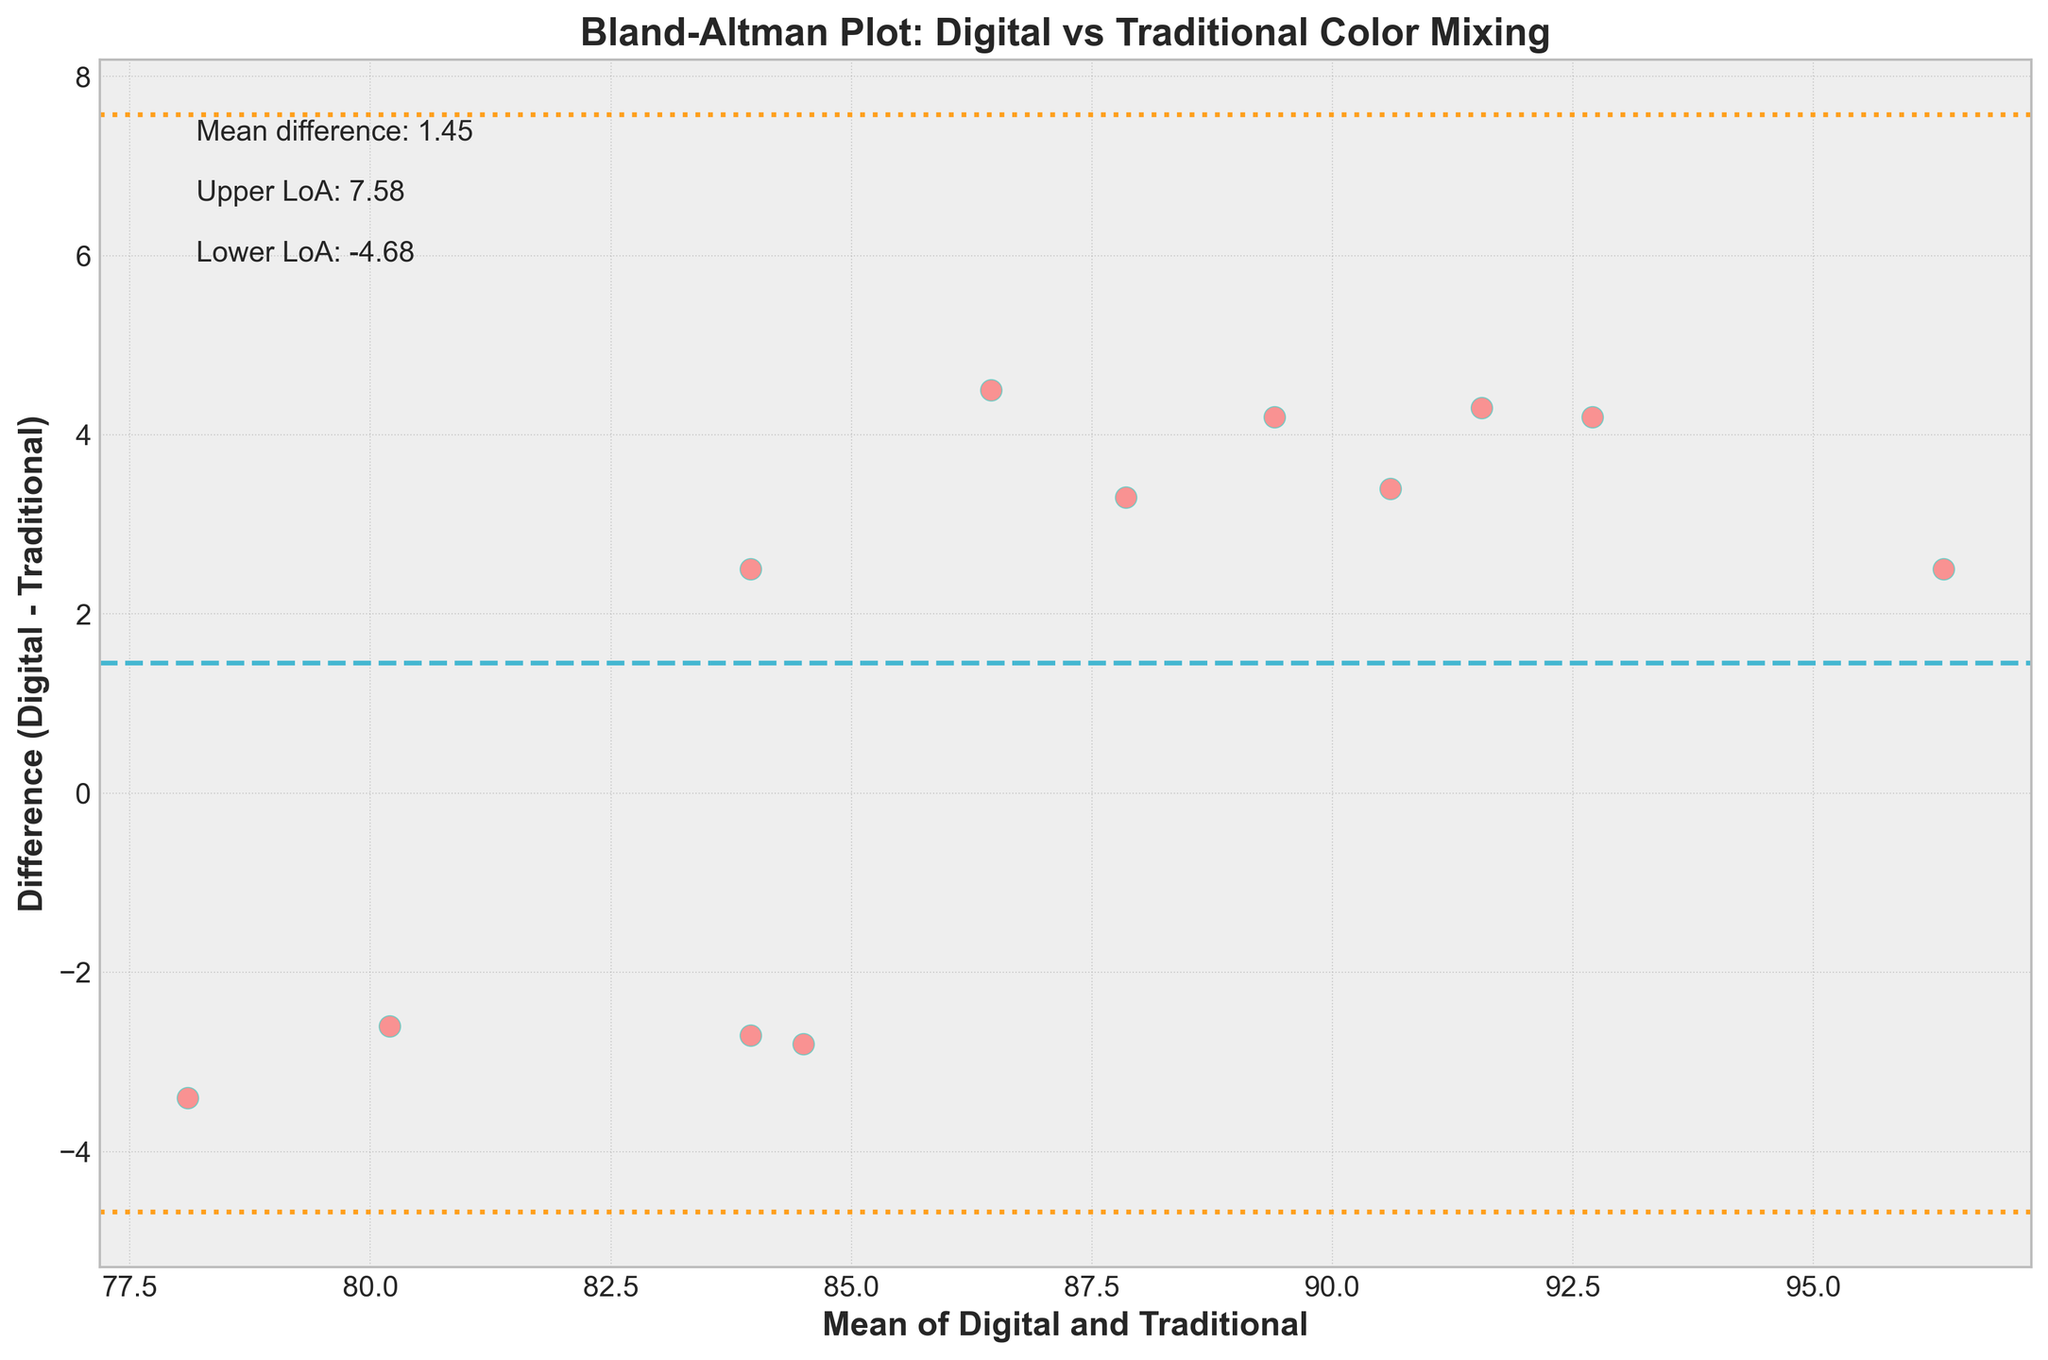What is the title of the plot? The title can be found at the top of the plot. It clearly states the focus of the plot.
Answer: Bland-Altman Plot: Digital vs Traditional Color Mixing What do the x and y axes represent? The x-axis represents the mean of Digital and Traditional methods, and the y-axis represents the difference between Digital and Traditional methods. This can be inferred from the axis labels on the plot.
Answer: The x-axis represents the mean of Digital and Traditional, and the y-axis represents the difference (Digital - Traditional) How many data points are plotted? By counting the number of scatter points on the plot, one can determine the number of data points.
Answer: 12 What is indicated by the dashed midpoint line in the plot? The midpoint line, indicated by a dashed line, represents the mean difference between the two methods being compared.
Answer: The mean difference What are the values of the upper and lower limits of agreement (LoA)? These values are provided in the annotations on the plot. The upper LoA is the mean difference plus 1.96 times the standard deviation of the difference, and the lower LoA is the mean difference minus 1.96 times the standard deviation of the difference.
Answer: Upper LoA: 5.63, Lower LoA: -3.93 What is the mean difference between the Digital and Traditional methods? The mean difference is shown as an annotation on the plot just above the dashed line. It represents the average difference between Digital and Traditional methods.
Answer: Mean difference: 0.85 Which data point has the largest positive difference and what is its value? Observing the scatter plot, the data point highest above the mean difference line corresponds to the largest positive difference. Its value can be read directly on the y-axis.
Answer: Phthalo Green Gradient, 4.5 Which color mixing method had a mean close to 90 and what was the difference? By identifying points on the x-axis near 90 and then checking the y-value (difference), the relevant color mixing method can be pinpointed.
Answer: Quinacridone Magenta Vibrancy, 4.3 Are there any points outside the limits of agreement? Points outside the upper and lower LoA lines (dotted lines) need to be checked. If none cross these lines, the answer is no points.
Answer: No What does it mean if a point lies above the mean difference line? Points above the mean difference line suggest that the Digital method produced higher values than the Traditional method for those mixing techniques.
Answer: Digital method produced higher values 